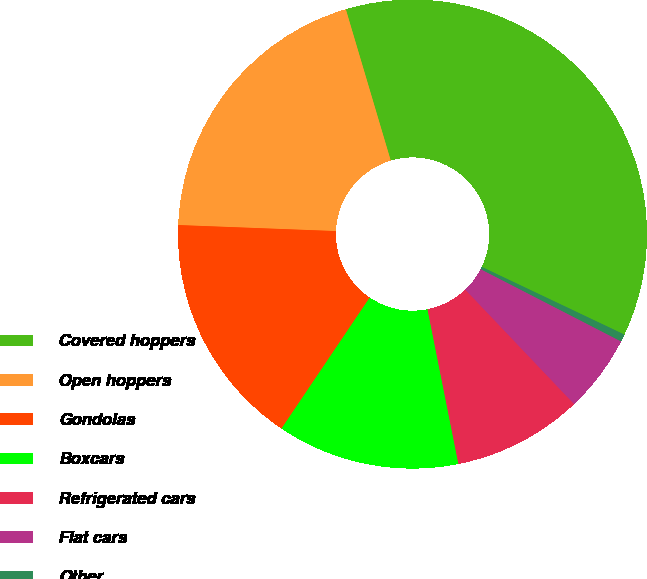Convert chart to OTSL. <chart><loc_0><loc_0><loc_500><loc_500><pie_chart><fcel>Covered hoppers<fcel>Open hoppers<fcel>Gondolas<fcel>Boxcars<fcel>Refrigerated cars<fcel>Flat cars<fcel>Other<nl><fcel>36.65%<fcel>19.8%<fcel>16.18%<fcel>12.57%<fcel>8.96%<fcel>5.34%<fcel>0.51%<nl></chart> 